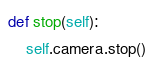<code> <loc_0><loc_0><loc_500><loc_500><_Python_>def stop(self):
    self.camera.stop()
</code> 